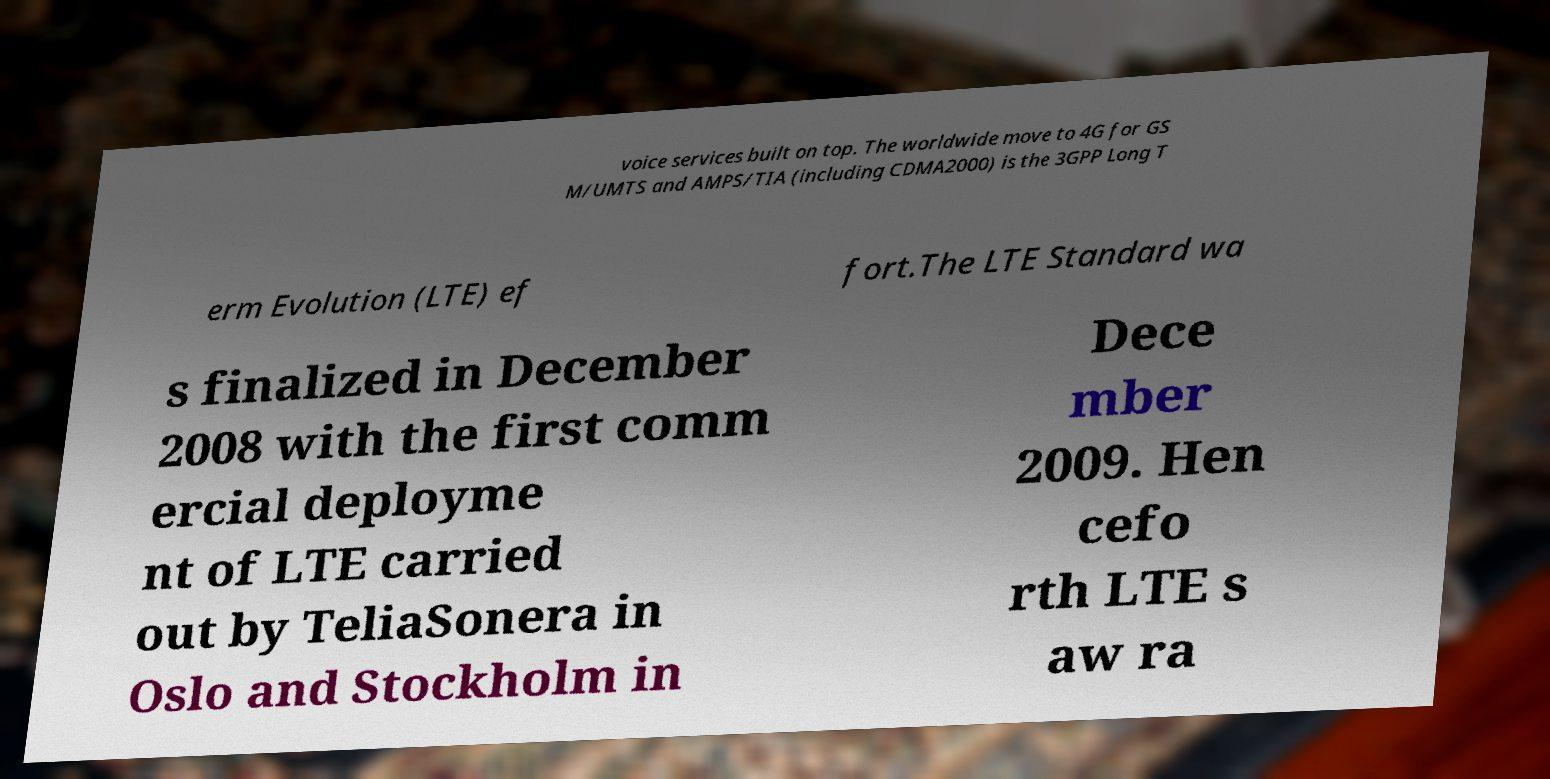There's text embedded in this image that I need extracted. Can you transcribe it verbatim? voice services built on top. The worldwide move to 4G for GS M/UMTS and AMPS/TIA (including CDMA2000) is the 3GPP Long T erm Evolution (LTE) ef fort.The LTE Standard wa s finalized in December 2008 with the first comm ercial deployme nt of LTE carried out by TeliaSonera in Oslo and Stockholm in Dece mber 2009. Hen cefo rth LTE s aw ra 